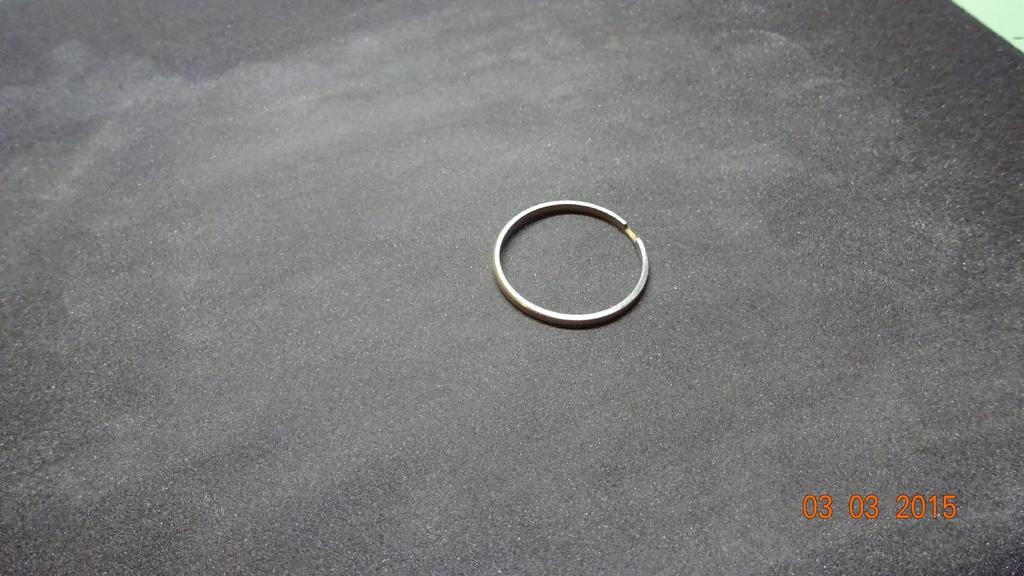What color are the numbers located in the bottom right of the image? The numbers in the bottom right of the image are orange in color. What object can be seen on the surface in the middle of the image? There is a ring on the surface in the middle of the image. What is the color of the background in the image? The background of the image is gray in color. Can you tell me how many toads are sitting on the ring in the image? There are no toads present in the image; it only features a ring on the surface. What type of station is visible in the background of the image? There is no station visible in the image; the background is gray in color. 